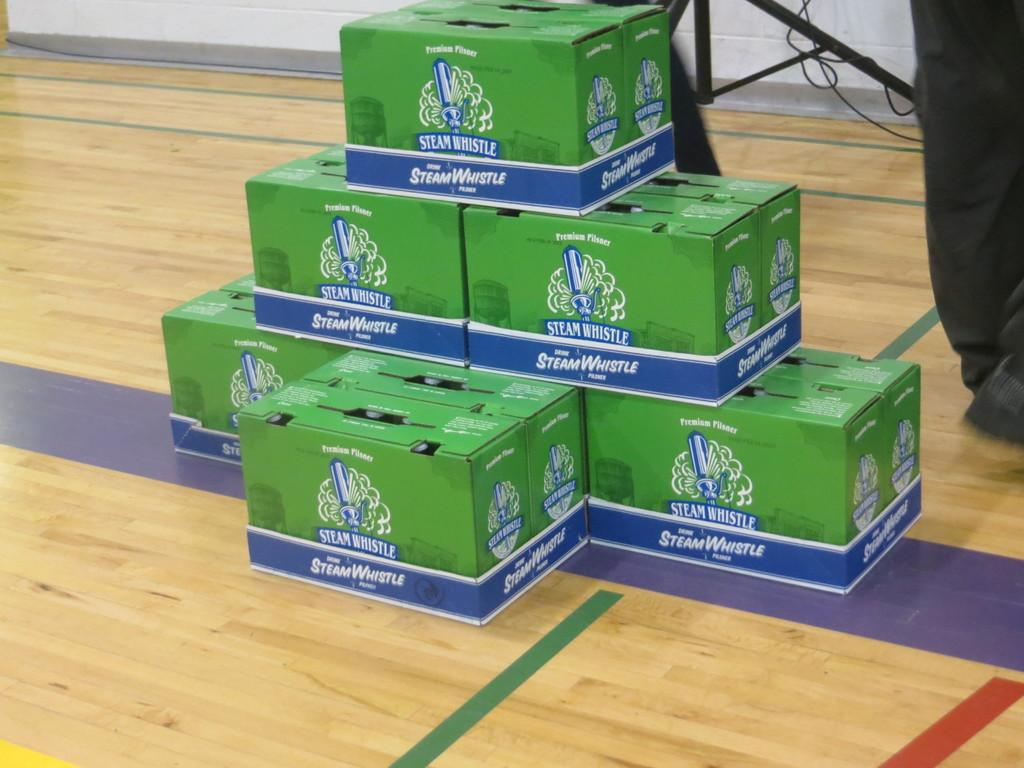<image>
Create a compact narrative representing the image presented. Green boxes of wine called Steam Whistle on a gym floor. 